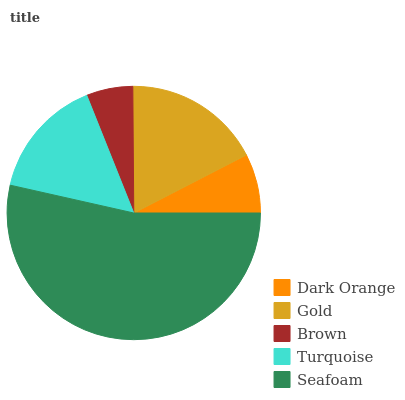Is Brown the minimum?
Answer yes or no. Yes. Is Seafoam the maximum?
Answer yes or no. Yes. Is Gold the minimum?
Answer yes or no. No. Is Gold the maximum?
Answer yes or no. No. Is Gold greater than Dark Orange?
Answer yes or no. Yes. Is Dark Orange less than Gold?
Answer yes or no. Yes. Is Dark Orange greater than Gold?
Answer yes or no. No. Is Gold less than Dark Orange?
Answer yes or no. No. Is Turquoise the high median?
Answer yes or no. Yes. Is Turquoise the low median?
Answer yes or no. Yes. Is Dark Orange the high median?
Answer yes or no. No. Is Brown the low median?
Answer yes or no. No. 